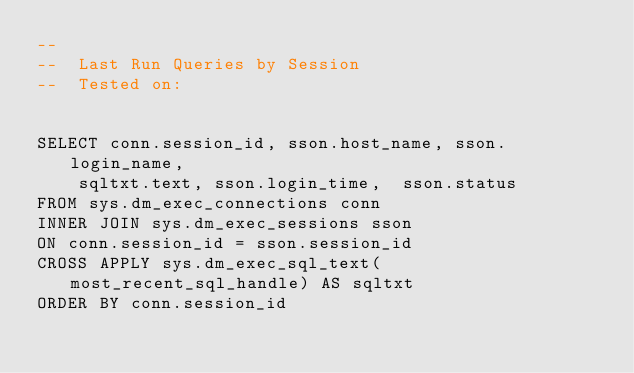Convert code to text. <code><loc_0><loc_0><loc_500><loc_500><_SQL_>--
--  Last Run Queries by Session
--  Tested on:


SELECT conn.session_id, sson.host_name, sson.login_name, 
	sqltxt.text, sson.login_time,  sson.status
FROM sys.dm_exec_connections conn
INNER JOIN sys.dm_exec_sessions sson 
ON conn.session_id = sson.session_id
CROSS APPLY sys.dm_exec_sql_text(most_recent_sql_handle) AS sqltxt
ORDER BY conn.session_id</code> 